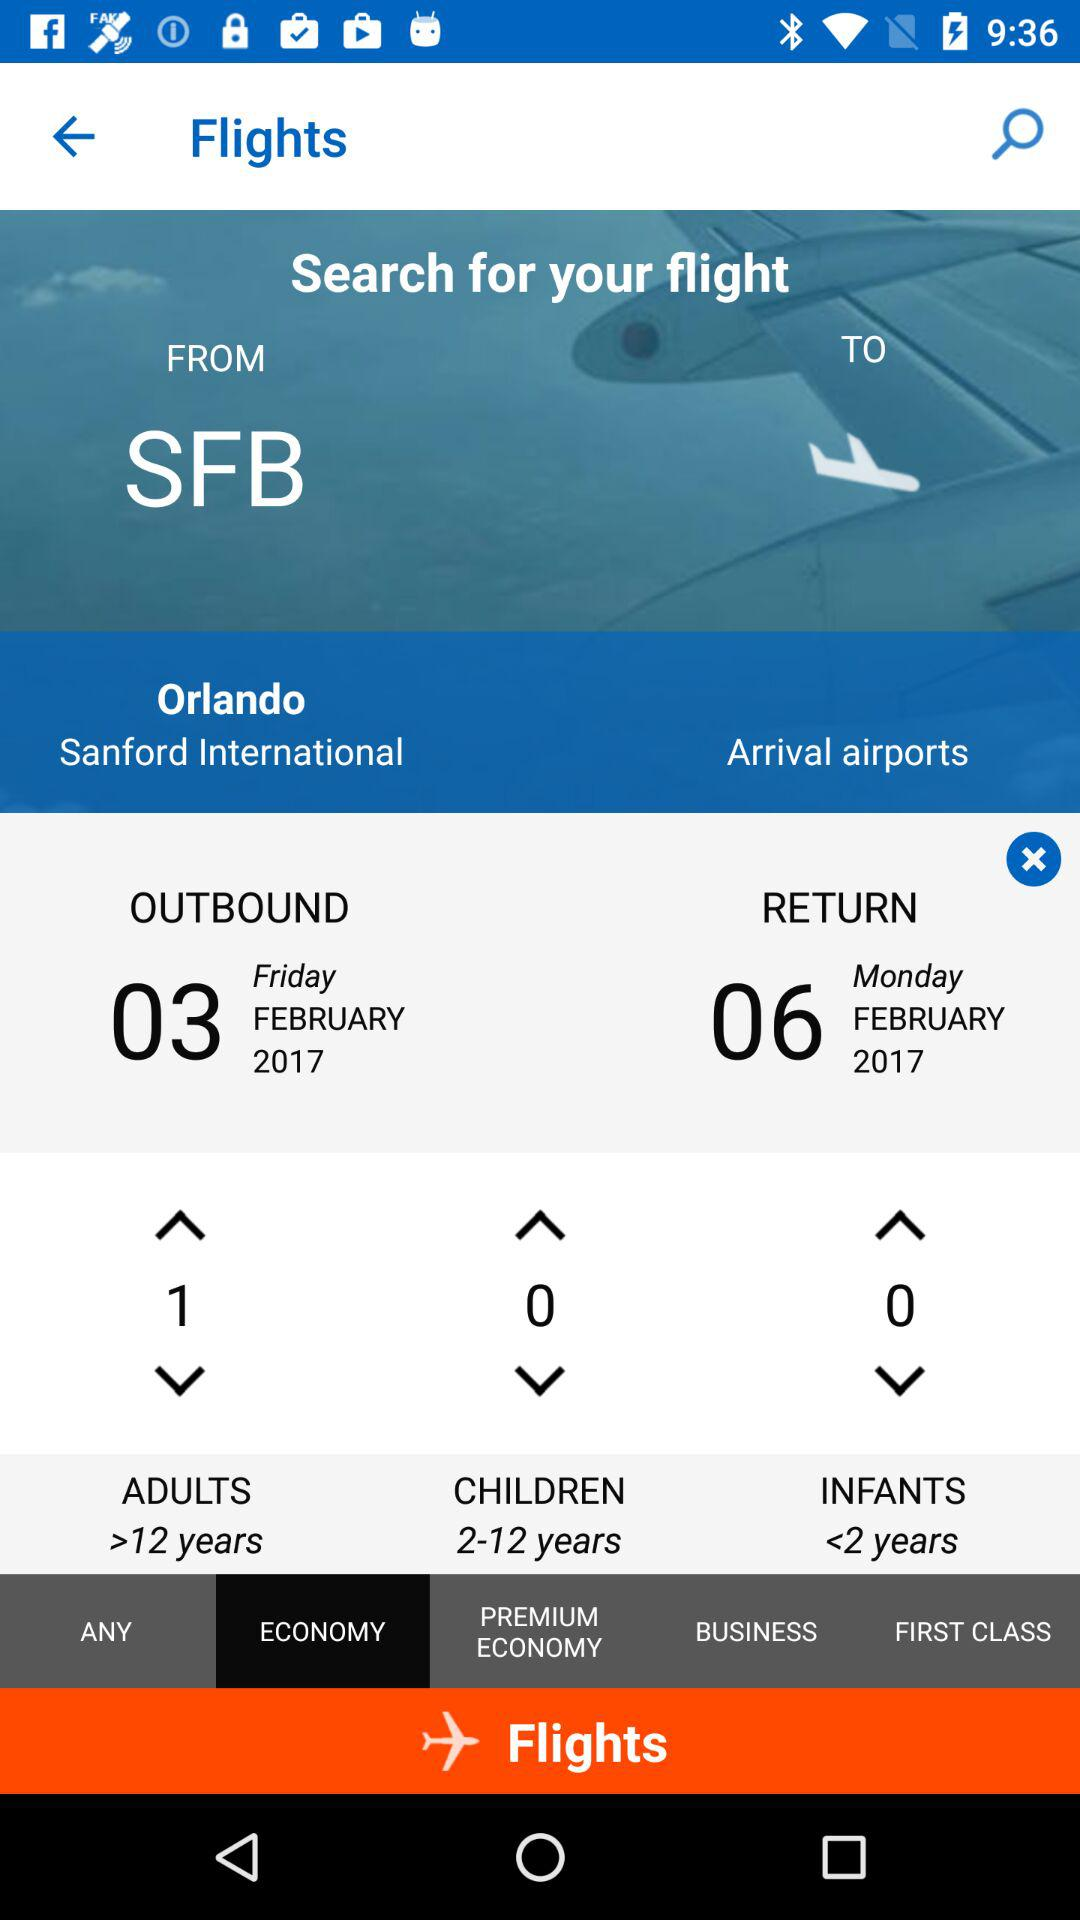How many infants are there? There are 0 infants. 